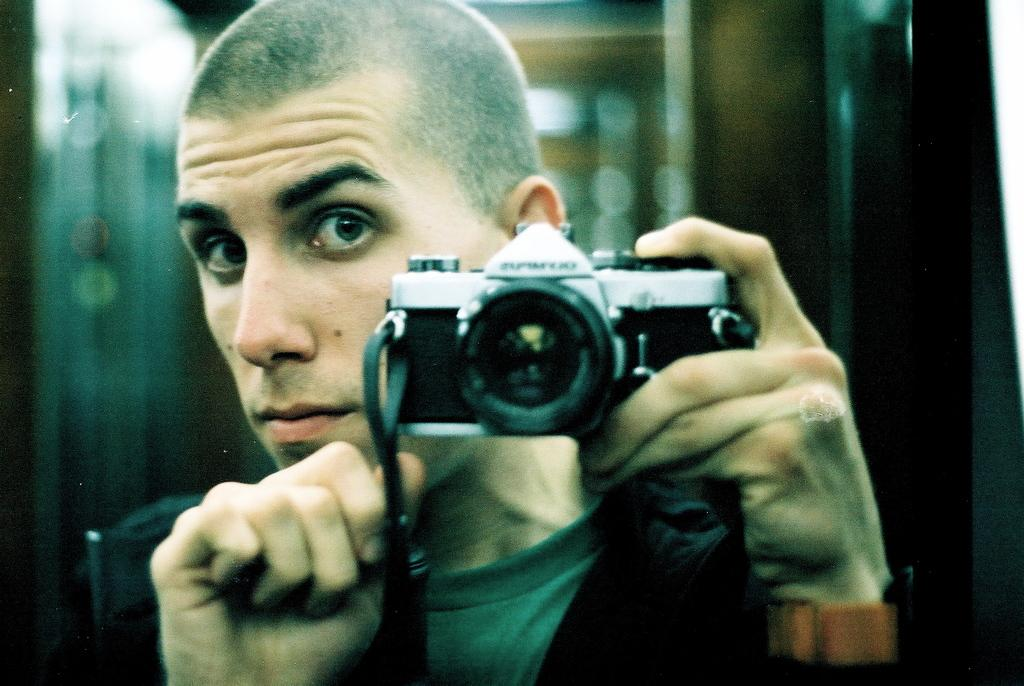Where was the image taken? The image is taken indoors. Can you describe the background of the image? The background of the image is blurred. What is the main subject of the image? There is a man in the middle of the image. What is the man holding in his hand? The man is holding a camera in his hand. How many dolls are sitting on the actor's lap in the image? There are no dolls or actors present in the image; it features a man holding a camera. What type of knot is tied around the man's neck in the image? There is no knot visible around the man's neck in the image. 